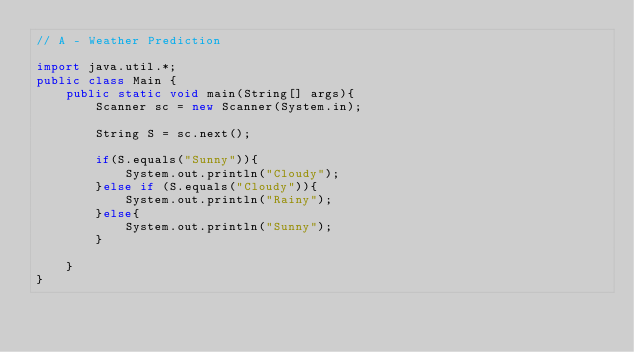Convert code to text. <code><loc_0><loc_0><loc_500><loc_500><_Java_>// A - Weather Prediction

import java.util.*;
public class Main {
	public static void main(String[] args){
		Scanner sc = new Scanner(System.in);

		String S = sc.next();

		if(S.equals("Sunny")){
			System.out.println("Cloudy");
		}else if (S.equals("Cloudy")){
			System.out.println("Rainy");
		}else{
			System.out.println("Sunny");
		}
		
	}
}</code> 